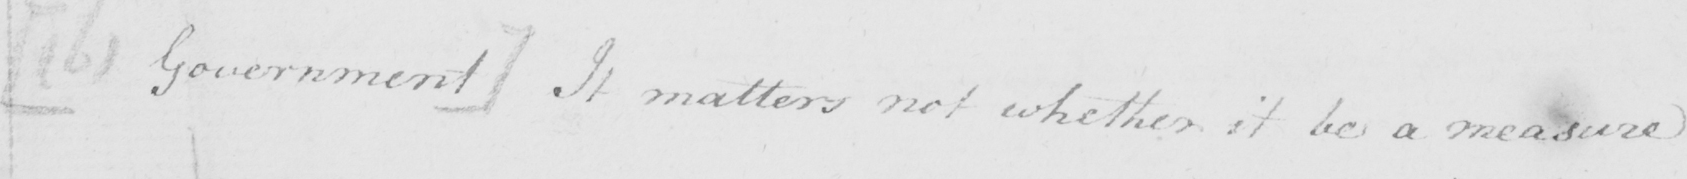Can you read and transcribe this handwriting? [  ( b )  Government ]  It matters not whether it be a measure 